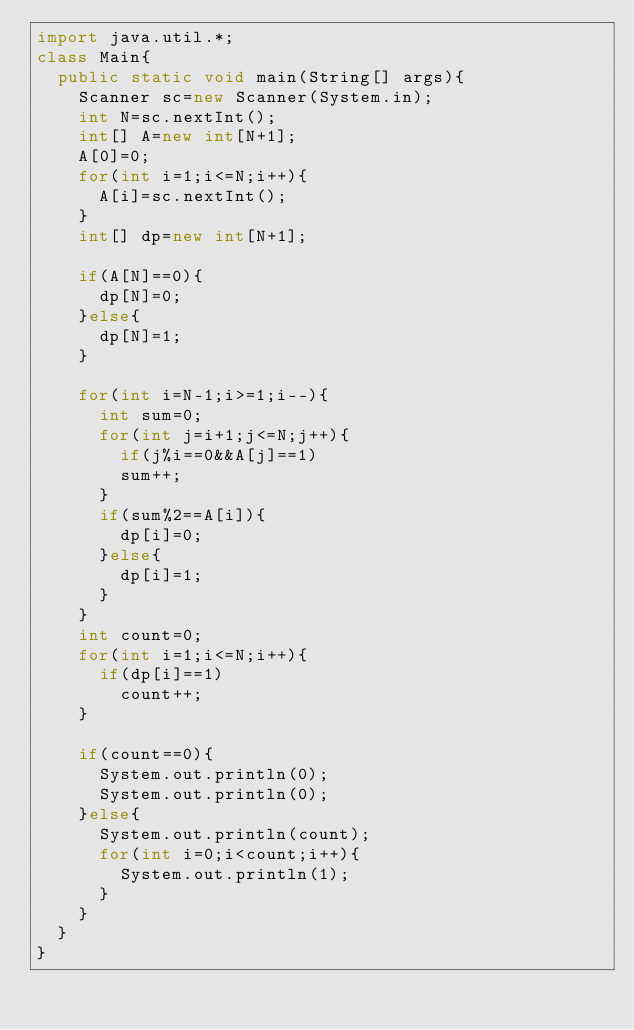Convert code to text. <code><loc_0><loc_0><loc_500><loc_500><_Java_>import java.util.*;
class Main{
	public static void main(String[] args){
		Scanner sc=new Scanner(System.in);
		int N=sc.nextInt();
		int[] A=new int[N+1];
		A[0]=0;
		for(int i=1;i<=N;i++){
			A[i]=sc.nextInt();
		}
		int[] dp=new int[N+1];
		
		if(A[N]==0){
			dp[N]=0;
		}else{
			dp[N]=1;
		}
		
		for(int i=N-1;i>=1;i--){
			int sum=0;
			for(int j=i+1;j<=N;j++){
				if(j%i==0&&A[j]==1)
				sum++;
			}
			if(sum%2==A[i]){
				dp[i]=0;
			}else{
				dp[i]=1;
			}
		}
		int count=0;
		for(int i=1;i<=N;i++){
			if(dp[i]==1)
				count++;
		}
		
		if(count==0){
			System.out.println(0);
			System.out.println(0);
		}else{
			System.out.println(count);
			for(int i=0;i<count;i++){
				System.out.println(1);
			}
		}
	}
}		
	</code> 